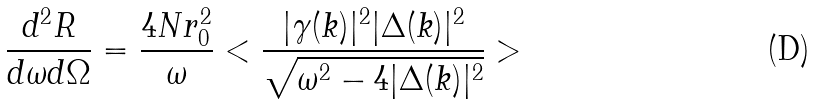Convert formula to latex. <formula><loc_0><loc_0><loc_500><loc_500>\frac { d ^ { 2 } R } { d \omega d \Omega } = \frac { 4 N r _ { 0 } ^ { 2 } } { \omega } < \frac { | \gamma ( { k } ) | ^ { 2 } | \Delta ( { k } ) | ^ { 2 } } { \sqrt { \omega ^ { 2 } - 4 | \Delta ( { k } ) | ^ { 2 } } } ></formula> 